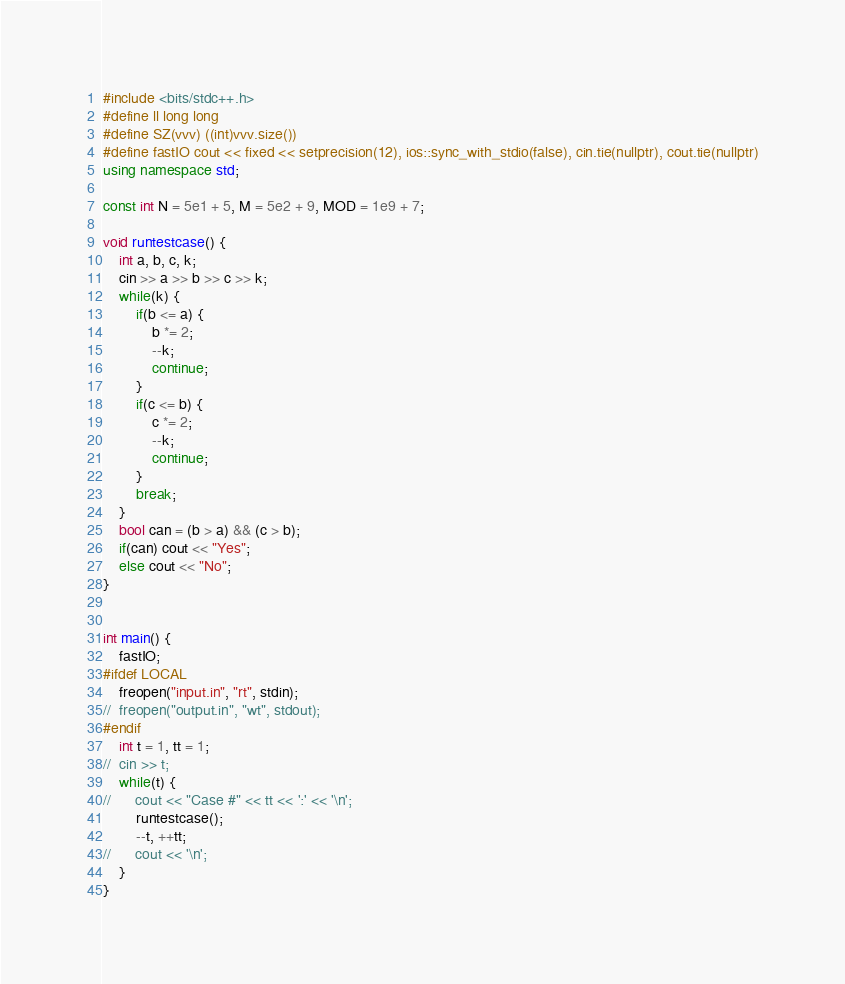<code> <loc_0><loc_0><loc_500><loc_500><_C++_>#include <bits/stdc++.h>
#define ll long long
#define SZ(vvv) ((int)vvv.size())
#define fastIO cout << fixed << setprecision(12), ios::sync_with_stdio(false), cin.tie(nullptr), cout.tie(nullptr)
using namespace std;

const int N = 5e1 + 5, M = 5e2 + 9, MOD = 1e9 + 7;

void runtestcase() {
	int a, b, c, k;
	cin >> a >> b >> c >> k;
	while(k) {
		if(b <= a) {
			b *= 2;
			--k;
			continue;
		}
		if(c <= b) {
			c *= 2;
			--k;
			continue;
		}
		break;
	}
	bool can = (b > a) && (c > b);
	if(can) cout << "Yes";
	else cout << "No";
}


int main() {
	fastIO;
#ifdef LOCAL
	freopen("input.in", "rt", stdin);
//	freopen("output.in", "wt", stdout);
#endif
	int t = 1, tt = 1;
//	cin >> t;
	while(t) {
//		cout << "Case #" << tt << ':' << '\n';
		runtestcase();
		--t, ++tt;
//		cout << '\n';
	}
}
</code> 